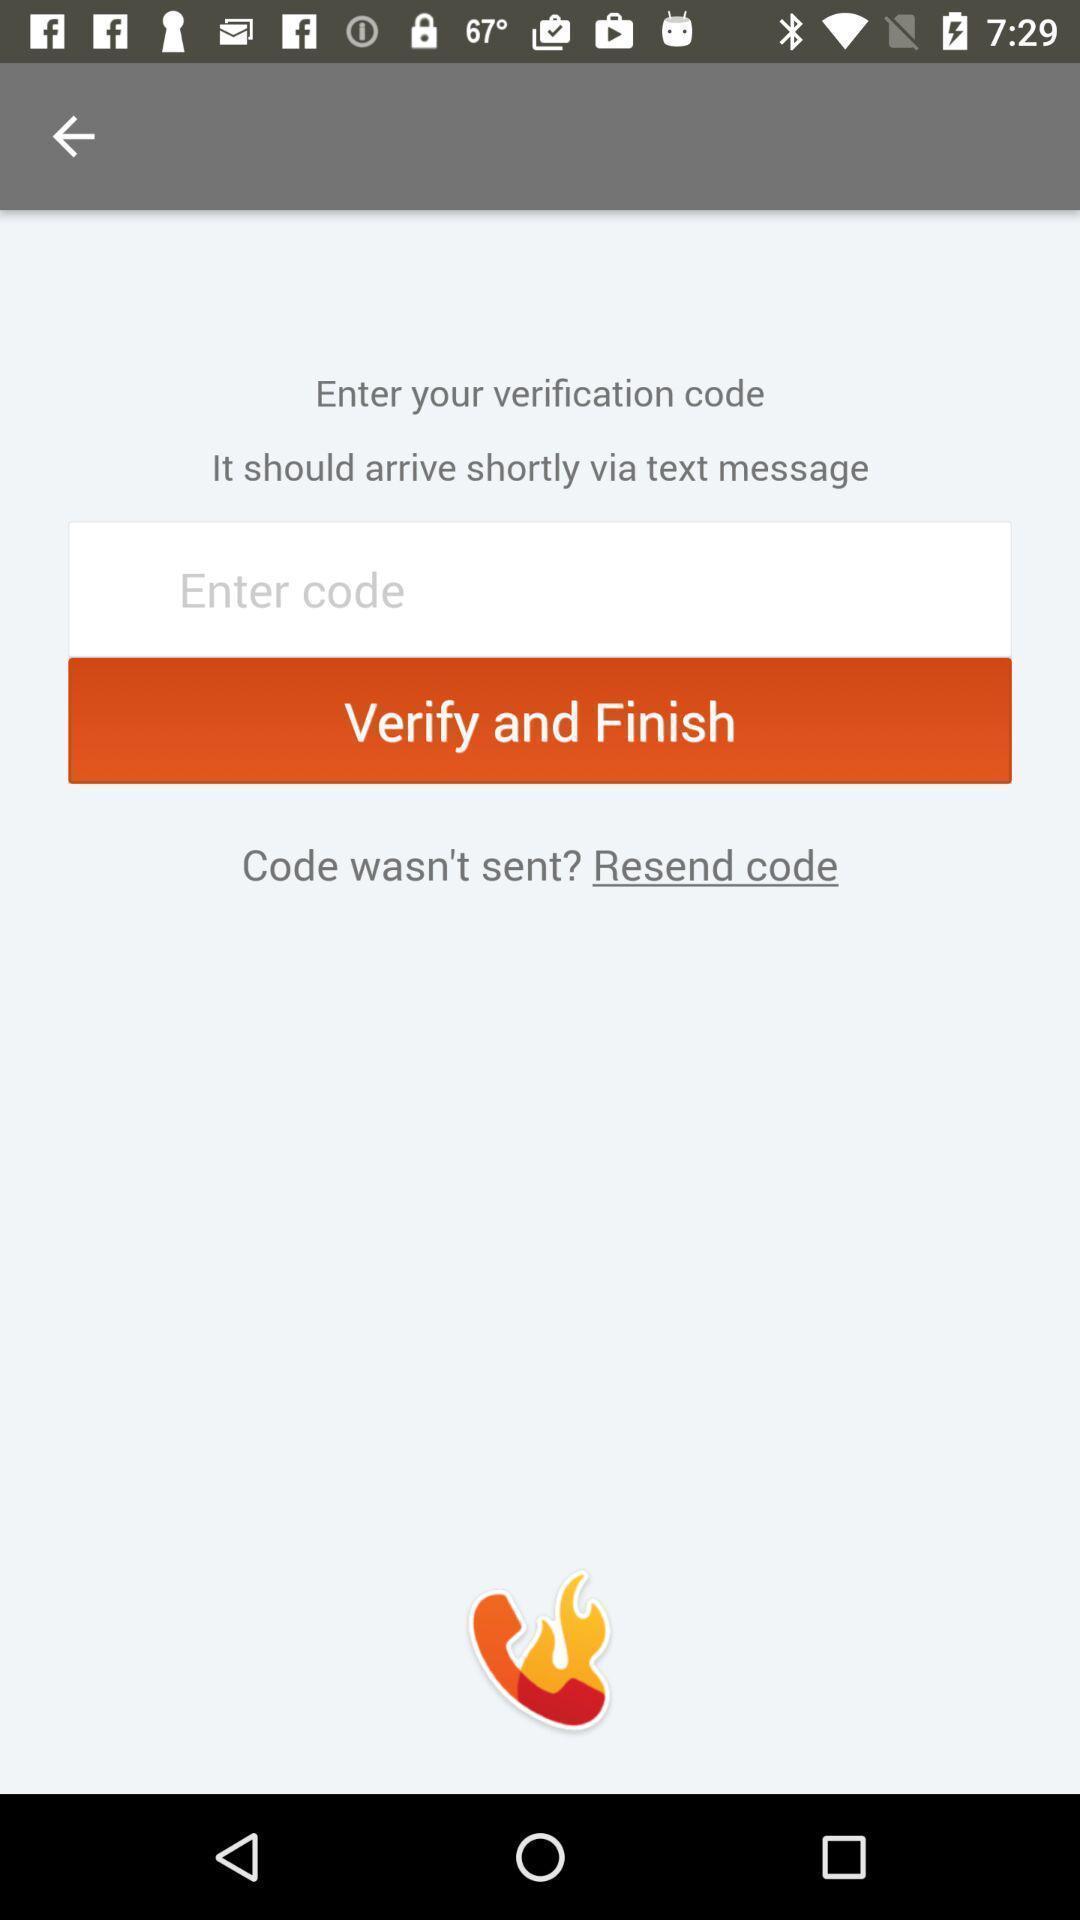Provide a description of this screenshot. Page request to enter code for verification. 